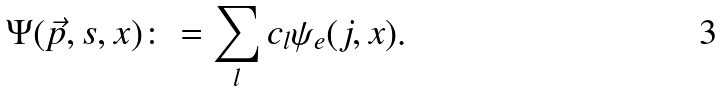<formula> <loc_0><loc_0><loc_500><loc_500>\Psi ( \vec { p } , s , x ) \colon = \sum _ { l } c _ { l } \psi _ { e } ( j , x ) .</formula> 